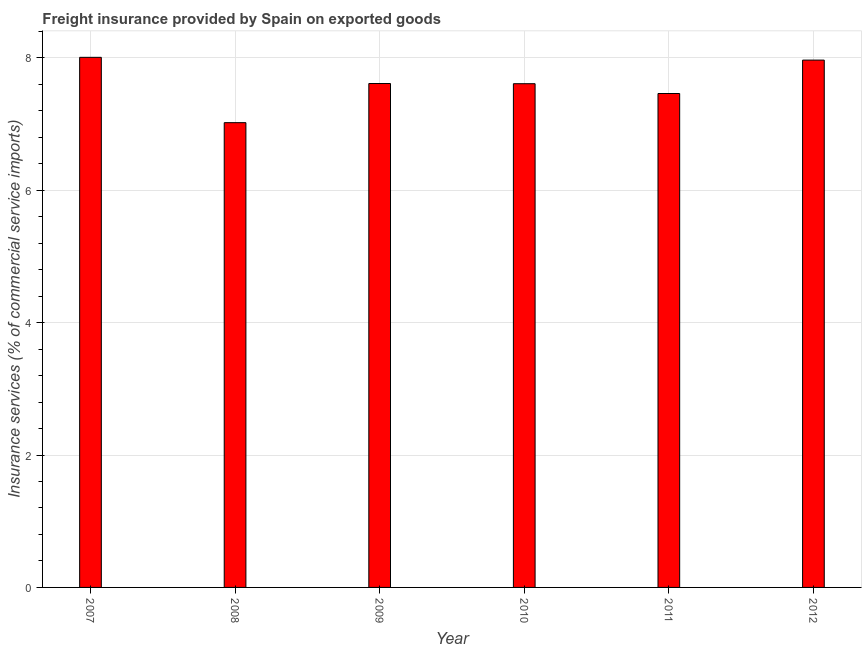Does the graph contain any zero values?
Your response must be concise. No. What is the title of the graph?
Your answer should be compact. Freight insurance provided by Spain on exported goods . What is the label or title of the X-axis?
Keep it short and to the point. Year. What is the label or title of the Y-axis?
Your answer should be very brief. Insurance services (% of commercial service imports). What is the freight insurance in 2010?
Your answer should be very brief. 7.61. Across all years, what is the maximum freight insurance?
Provide a short and direct response. 8.01. Across all years, what is the minimum freight insurance?
Give a very brief answer. 7.02. What is the sum of the freight insurance?
Make the answer very short. 45.68. What is the difference between the freight insurance in 2007 and 2011?
Keep it short and to the point. 0.55. What is the average freight insurance per year?
Keep it short and to the point. 7.61. What is the median freight insurance?
Give a very brief answer. 7.61. In how many years, is the freight insurance greater than 1.2 %?
Give a very brief answer. 6. What is the ratio of the freight insurance in 2007 to that in 2010?
Your response must be concise. 1.05. Is the freight insurance in 2007 less than that in 2010?
Make the answer very short. No. What is the difference between the highest and the second highest freight insurance?
Your answer should be compact. 0.04. Is the sum of the freight insurance in 2009 and 2011 greater than the maximum freight insurance across all years?
Your response must be concise. Yes. What is the difference between the highest and the lowest freight insurance?
Provide a short and direct response. 0.99. In how many years, is the freight insurance greater than the average freight insurance taken over all years?
Give a very brief answer. 2. How many bars are there?
Give a very brief answer. 6. How many years are there in the graph?
Offer a very short reply. 6. Are the values on the major ticks of Y-axis written in scientific E-notation?
Make the answer very short. No. What is the Insurance services (% of commercial service imports) in 2007?
Your answer should be very brief. 8.01. What is the Insurance services (% of commercial service imports) of 2008?
Your answer should be compact. 7.02. What is the Insurance services (% of commercial service imports) of 2009?
Offer a very short reply. 7.61. What is the Insurance services (% of commercial service imports) of 2010?
Your answer should be very brief. 7.61. What is the Insurance services (% of commercial service imports) in 2011?
Your answer should be very brief. 7.46. What is the Insurance services (% of commercial service imports) in 2012?
Provide a succinct answer. 7.97. What is the difference between the Insurance services (% of commercial service imports) in 2007 and 2008?
Give a very brief answer. 0.99. What is the difference between the Insurance services (% of commercial service imports) in 2007 and 2009?
Offer a very short reply. 0.4. What is the difference between the Insurance services (% of commercial service imports) in 2007 and 2010?
Offer a terse response. 0.4. What is the difference between the Insurance services (% of commercial service imports) in 2007 and 2011?
Offer a terse response. 0.55. What is the difference between the Insurance services (% of commercial service imports) in 2007 and 2012?
Keep it short and to the point. 0.04. What is the difference between the Insurance services (% of commercial service imports) in 2008 and 2009?
Your answer should be very brief. -0.59. What is the difference between the Insurance services (% of commercial service imports) in 2008 and 2010?
Keep it short and to the point. -0.59. What is the difference between the Insurance services (% of commercial service imports) in 2008 and 2011?
Offer a terse response. -0.44. What is the difference between the Insurance services (% of commercial service imports) in 2008 and 2012?
Offer a terse response. -0.95. What is the difference between the Insurance services (% of commercial service imports) in 2009 and 2010?
Your answer should be very brief. 0. What is the difference between the Insurance services (% of commercial service imports) in 2009 and 2011?
Offer a terse response. 0.15. What is the difference between the Insurance services (% of commercial service imports) in 2009 and 2012?
Your answer should be very brief. -0.35. What is the difference between the Insurance services (% of commercial service imports) in 2010 and 2011?
Give a very brief answer. 0.15. What is the difference between the Insurance services (% of commercial service imports) in 2010 and 2012?
Offer a very short reply. -0.36. What is the difference between the Insurance services (% of commercial service imports) in 2011 and 2012?
Offer a very short reply. -0.5. What is the ratio of the Insurance services (% of commercial service imports) in 2007 to that in 2008?
Your answer should be compact. 1.14. What is the ratio of the Insurance services (% of commercial service imports) in 2007 to that in 2009?
Provide a succinct answer. 1.05. What is the ratio of the Insurance services (% of commercial service imports) in 2007 to that in 2010?
Make the answer very short. 1.05. What is the ratio of the Insurance services (% of commercial service imports) in 2007 to that in 2011?
Your response must be concise. 1.07. What is the ratio of the Insurance services (% of commercial service imports) in 2007 to that in 2012?
Your response must be concise. 1. What is the ratio of the Insurance services (% of commercial service imports) in 2008 to that in 2009?
Your answer should be compact. 0.92. What is the ratio of the Insurance services (% of commercial service imports) in 2008 to that in 2010?
Keep it short and to the point. 0.92. What is the ratio of the Insurance services (% of commercial service imports) in 2008 to that in 2011?
Provide a short and direct response. 0.94. What is the ratio of the Insurance services (% of commercial service imports) in 2008 to that in 2012?
Keep it short and to the point. 0.88. What is the ratio of the Insurance services (% of commercial service imports) in 2009 to that in 2011?
Provide a succinct answer. 1.02. What is the ratio of the Insurance services (% of commercial service imports) in 2009 to that in 2012?
Offer a very short reply. 0.96. What is the ratio of the Insurance services (% of commercial service imports) in 2010 to that in 2011?
Offer a terse response. 1.02. What is the ratio of the Insurance services (% of commercial service imports) in 2010 to that in 2012?
Make the answer very short. 0.95. What is the ratio of the Insurance services (% of commercial service imports) in 2011 to that in 2012?
Provide a short and direct response. 0.94. 